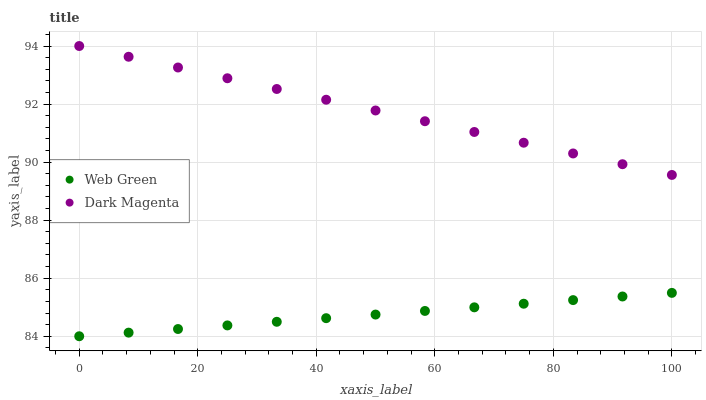Does Web Green have the minimum area under the curve?
Answer yes or no. Yes. Does Dark Magenta have the maximum area under the curve?
Answer yes or no. Yes. Does Web Green have the maximum area under the curve?
Answer yes or no. No. Is Web Green the smoothest?
Answer yes or no. Yes. Is Dark Magenta the roughest?
Answer yes or no. Yes. Is Web Green the roughest?
Answer yes or no. No. Does Web Green have the lowest value?
Answer yes or no. Yes. Does Dark Magenta have the highest value?
Answer yes or no. Yes. Does Web Green have the highest value?
Answer yes or no. No. Is Web Green less than Dark Magenta?
Answer yes or no. Yes. Is Dark Magenta greater than Web Green?
Answer yes or no. Yes. Does Web Green intersect Dark Magenta?
Answer yes or no. No. 